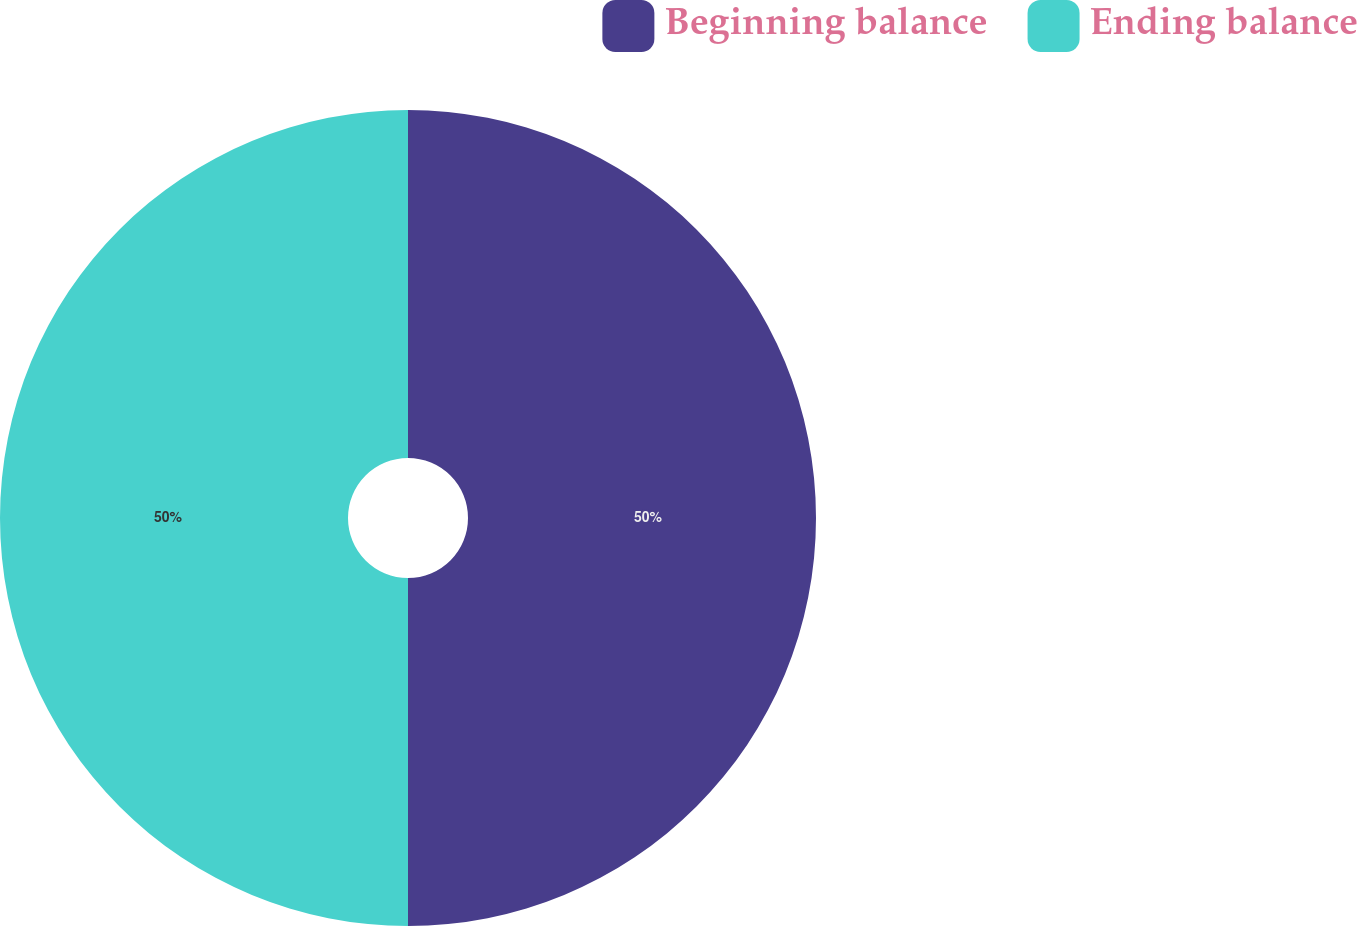<chart> <loc_0><loc_0><loc_500><loc_500><pie_chart><fcel>Beginning balance<fcel>Ending balance<nl><fcel>50.0%<fcel>50.0%<nl></chart> 